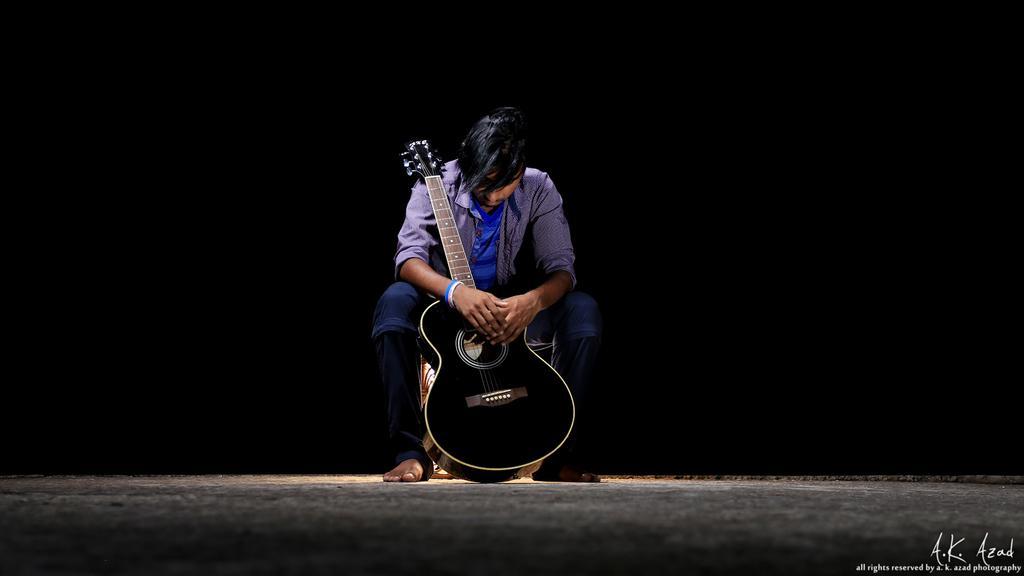In one or two sentences, can you explain what this image depicts? A human is sat on the table. We can see he is holding a guitar. 